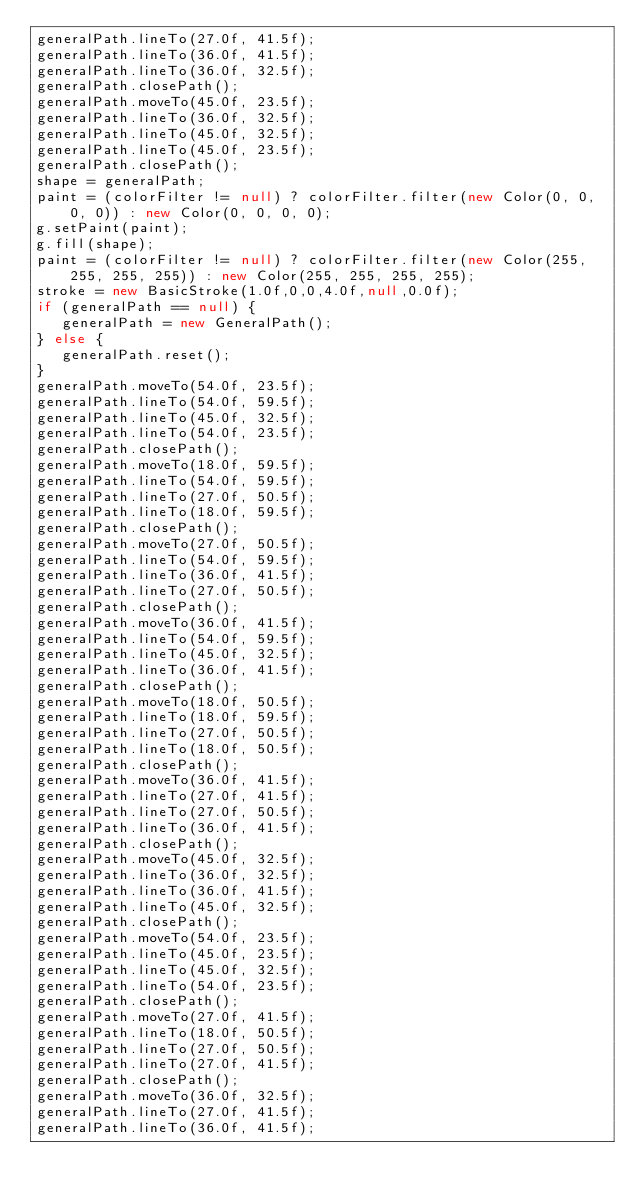Convert code to text. <code><loc_0><loc_0><loc_500><loc_500><_Java_>generalPath.lineTo(27.0f, 41.5f);
generalPath.lineTo(36.0f, 41.5f);
generalPath.lineTo(36.0f, 32.5f);
generalPath.closePath();
generalPath.moveTo(45.0f, 23.5f);
generalPath.lineTo(36.0f, 32.5f);
generalPath.lineTo(45.0f, 32.5f);
generalPath.lineTo(45.0f, 23.5f);
generalPath.closePath();
shape = generalPath;
paint = (colorFilter != null) ? colorFilter.filter(new Color(0, 0, 0, 0)) : new Color(0, 0, 0, 0);
g.setPaint(paint);
g.fill(shape);
paint = (colorFilter != null) ? colorFilter.filter(new Color(255, 255, 255, 255)) : new Color(255, 255, 255, 255);
stroke = new BasicStroke(1.0f,0,0,4.0f,null,0.0f);
if (generalPath == null) {
   generalPath = new GeneralPath();
} else {
   generalPath.reset();
}
generalPath.moveTo(54.0f, 23.5f);
generalPath.lineTo(54.0f, 59.5f);
generalPath.lineTo(45.0f, 32.5f);
generalPath.lineTo(54.0f, 23.5f);
generalPath.closePath();
generalPath.moveTo(18.0f, 59.5f);
generalPath.lineTo(54.0f, 59.5f);
generalPath.lineTo(27.0f, 50.5f);
generalPath.lineTo(18.0f, 59.5f);
generalPath.closePath();
generalPath.moveTo(27.0f, 50.5f);
generalPath.lineTo(54.0f, 59.5f);
generalPath.lineTo(36.0f, 41.5f);
generalPath.lineTo(27.0f, 50.5f);
generalPath.closePath();
generalPath.moveTo(36.0f, 41.5f);
generalPath.lineTo(54.0f, 59.5f);
generalPath.lineTo(45.0f, 32.5f);
generalPath.lineTo(36.0f, 41.5f);
generalPath.closePath();
generalPath.moveTo(18.0f, 50.5f);
generalPath.lineTo(18.0f, 59.5f);
generalPath.lineTo(27.0f, 50.5f);
generalPath.lineTo(18.0f, 50.5f);
generalPath.closePath();
generalPath.moveTo(36.0f, 41.5f);
generalPath.lineTo(27.0f, 41.5f);
generalPath.lineTo(27.0f, 50.5f);
generalPath.lineTo(36.0f, 41.5f);
generalPath.closePath();
generalPath.moveTo(45.0f, 32.5f);
generalPath.lineTo(36.0f, 32.5f);
generalPath.lineTo(36.0f, 41.5f);
generalPath.lineTo(45.0f, 32.5f);
generalPath.closePath();
generalPath.moveTo(54.0f, 23.5f);
generalPath.lineTo(45.0f, 23.5f);
generalPath.lineTo(45.0f, 32.5f);
generalPath.lineTo(54.0f, 23.5f);
generalPath.closePath();
generalPath.moveTo(27.0f, 41.5f);
generalPath.lineTo(18.0f, 50.5f);
generalPath.lineTo(27.0f, 50.5f);
generalPath.lineTo(27.0f, 41.5f);
generalPath.closePath();
generalPath.moveTo(36.0f, 32.5f);
generalPath.lineTo(27.0f, 41.5f);
generalPath.lineTo(36.0f, 41.5f);</code> 